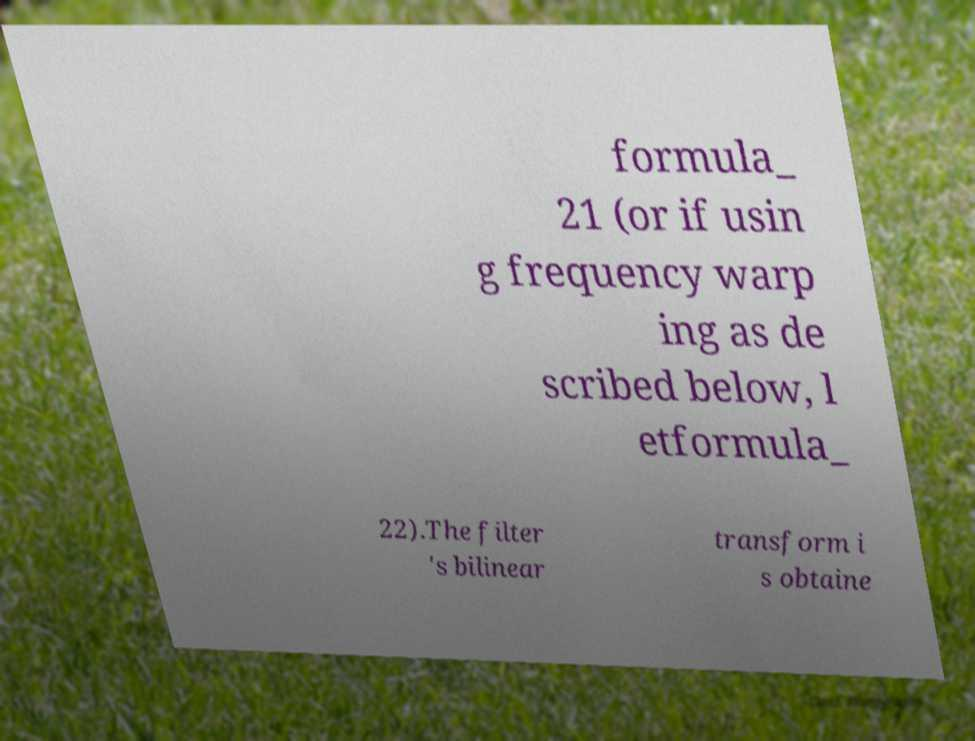What messages or text are displayed in this image? I need them in a readable, typed format. formula_ 21 (or if usin g frequency warp ing as de scribed below, l etformula_ 22).The filter 's bilinear transform i s obtaine 